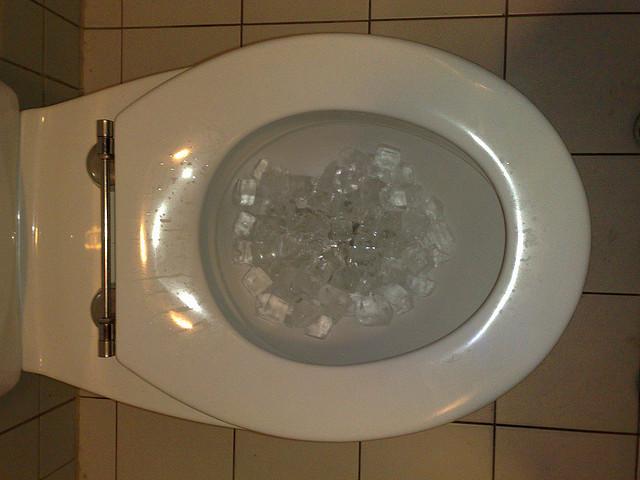What is the floor made of?
Concise answer only. Tile. Does this toilet look like it needs to be flushed?
Quick response, please. Yes. Does the toilet have a lid?
Give a very brief answer. No. Is this a normal toilet seat like everyone else?
Write a very short answer. Yes. What is in the toilet?
Be succinct. Ice. 